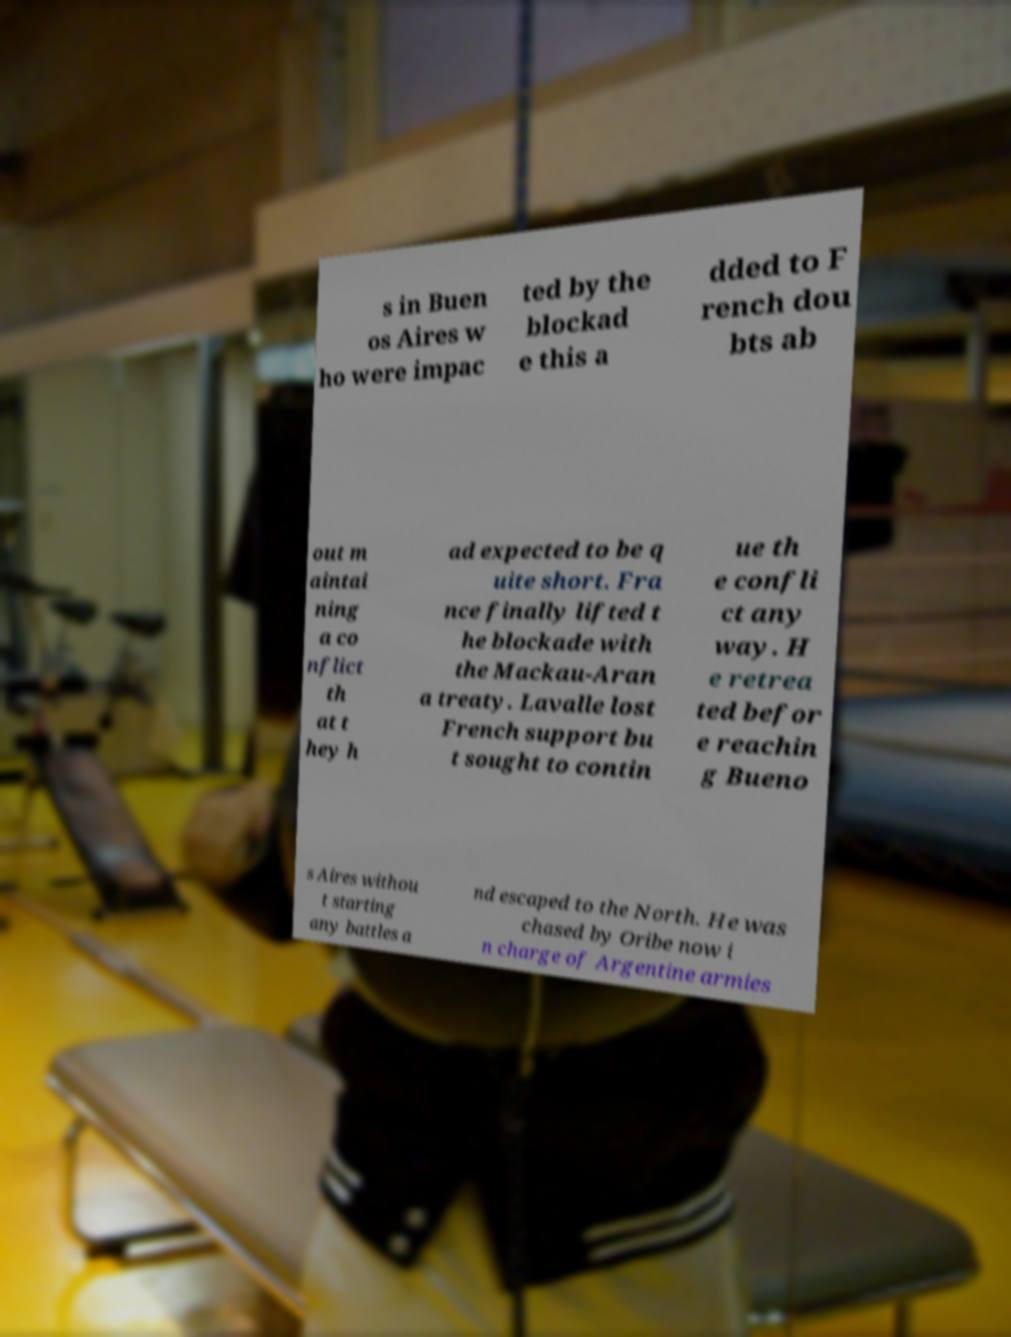Can you read and provide the text displayed in the image?This photo seems to have some interesting text. Can you extract and type it out for me? s in Buen os Aires w ho were impac ted by the blockad e this a dded to F rench dou bts ab out m aintai ning a co nflict th at t hey h ad expected to be q uite short. Fra nce finally lifted t he blockade with the Mackau-Aran a treaty. Lavalle lost French support bu t sought to contin ue th e confli ct any way. H e retrea ted befor e reachin g Bueno s Aires withou t starting any battles a nd escaped to the North. He was chased by Oribe now i n charge of Argentine armies 